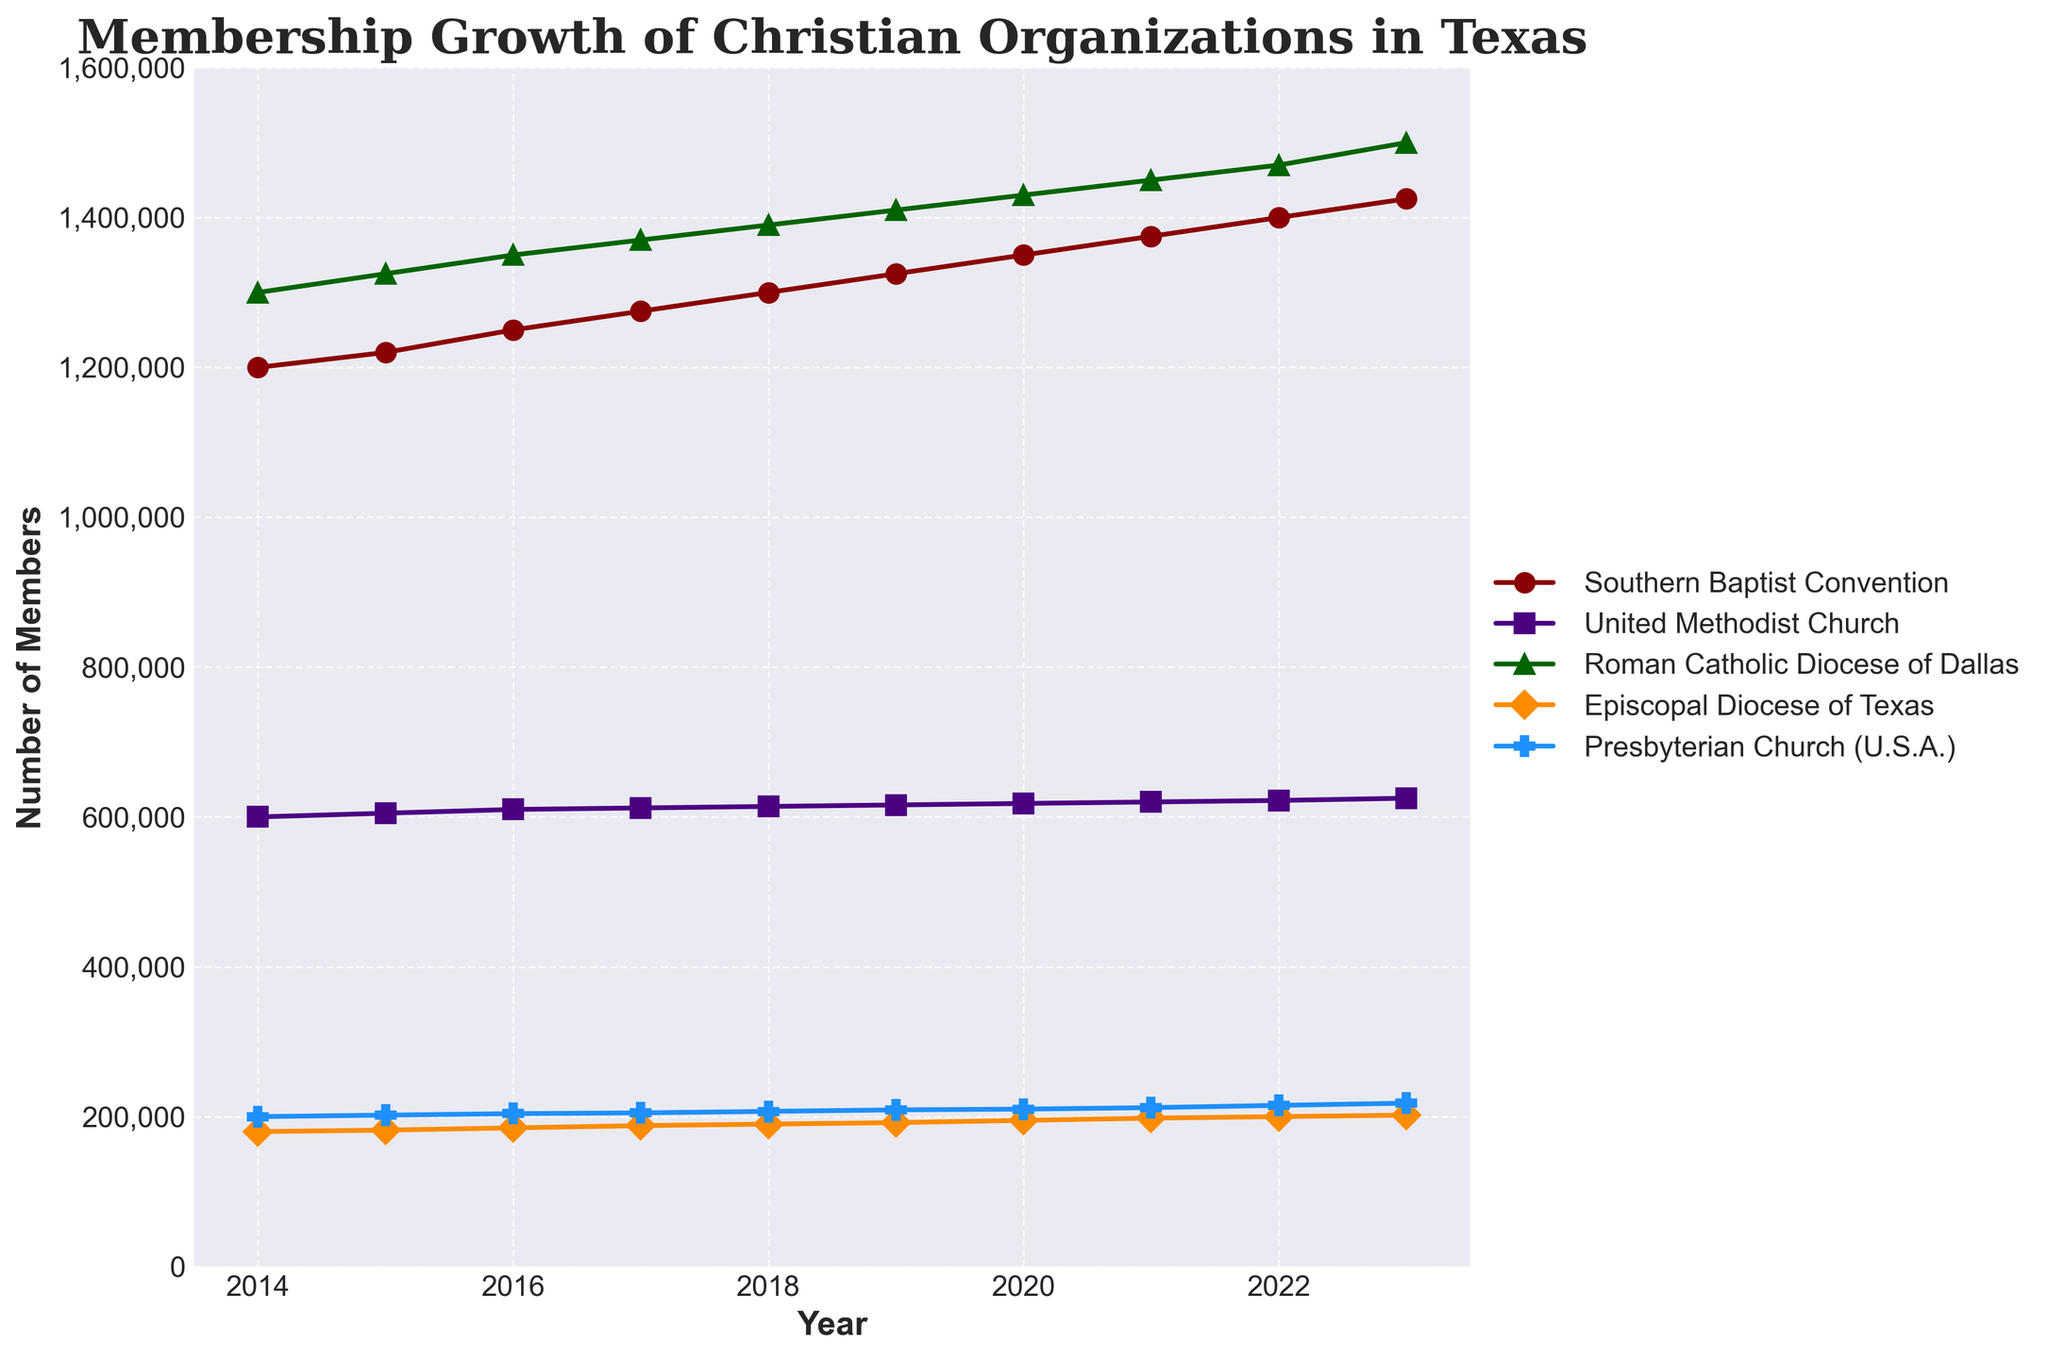What is the title of the plot? The title of the plot is given at the top of the figure.
Answer: Membership Growth of Christian Organizations in Texas How many Christian organizations are represented in the plot? The plot has lines for each Christian organization, and the legend can be used to count them.
Answer: 5 What is the maximum membership of the Roman Catholic Diocese of Dallas during the period shown? By looking at the line for the Roman Catholic Diocese of Dallas and identifying its highest point, we see the corresponding value on the y-axis.
Answer: 1,500,000 Which organization had the lowest membership in 2014? By comparing the data points for each organization at 2014, the Episcopal Diocese of Texas has the lowest value on the y-axis.
Answer: Episcopal Diocese of Texas What was the annual growth rate of the Southern Baptist Convention from 2019 to 2020? Find the difference between 2020 and 2019 values for the Southern Baptist Convention and divide by the 2019 value: (1,350,000 - 1,325,000) / 1,325,000 = 0.0189.
Answer: 1.89% Which organization experienced the largest increase in membership from 2014 to 2023? Calculate the difference between the 2023 and 2014 membership values for each organization and compare them. The Roman Catholic Diocese of Dallas had the largest increase of 200,000 members.
Answer: Roman Catholic Diocese of Dallas In which year did the Presbyterian Church (U.S.A.) have 205,000 members? Follow the line for the Presbyterian Church (U.S.A.) and identify the year corresponding to the 205,000 members on the y-axis.
Answer: 2017 What is the average membership number of the United Methodist Church from 2014 to 2023? Sum the membership values of the United Methodist Church from 2014 to 2023 and divide by the number of years: (600,000 + 605,000 + 610,000 + 612,000 + 614,000 + 616,000 + 618,000 + 620,000 + 622,000 + 625,000) / 10 = 611,200.
Answer: 611,200 Between which years did the Episcopal Diocese of Texas experience the most significant increase in membership? By examining the slope or comparing year-to-year increases, the largest difference is from 2020 to 2021 with an increase of 3,000 members.
Answer: 2020 to 2021 